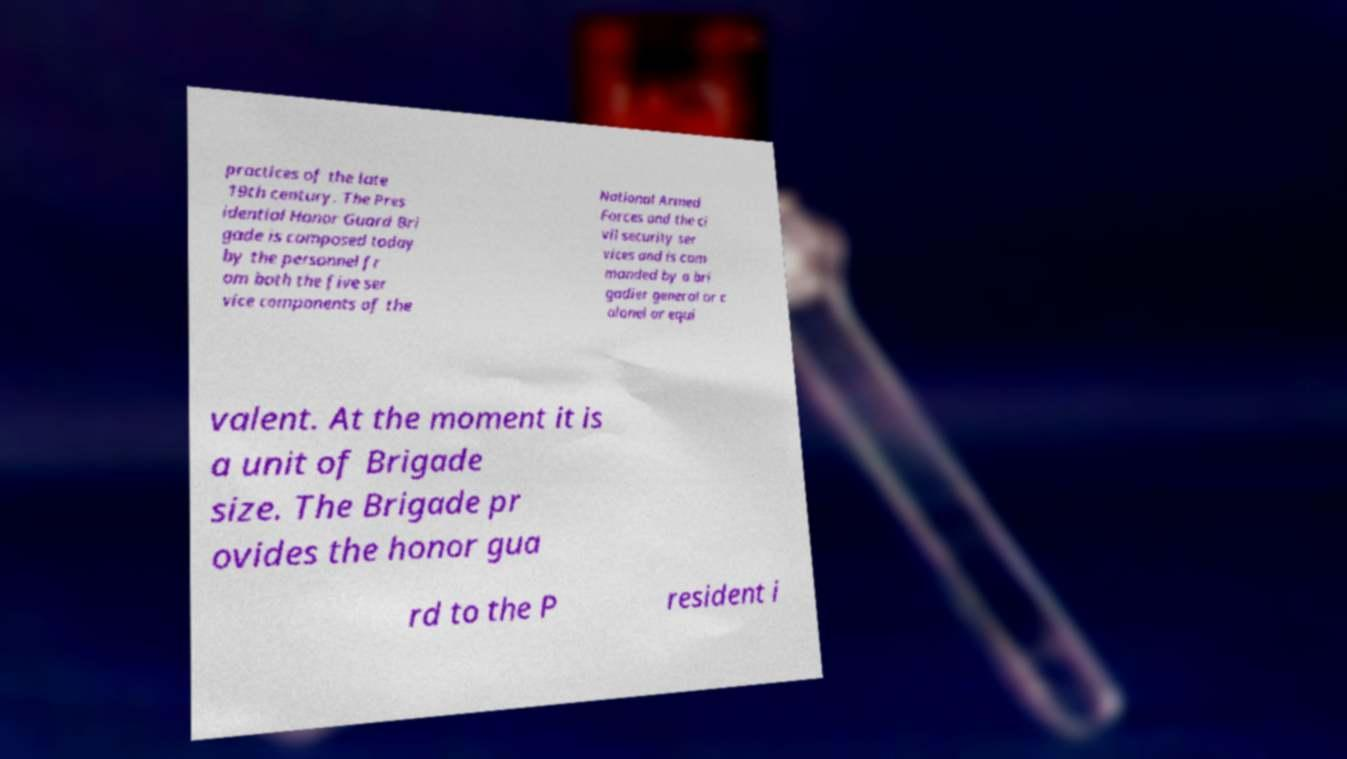Could you assist in decoding the text presented in this image and type it out clearly? practices of the late 19th century. The Pres idential Honor Guard Bri gade is composed today by the personnel fr om both the five ser vice components of the National Armed Forces and the ci vil security ser vices and is com manded by a bri gadier general or c olonel or equi valent. At the moment it is a unit of Brigade size. The Brigade pr ovides the honor gua rd to the P resident i 